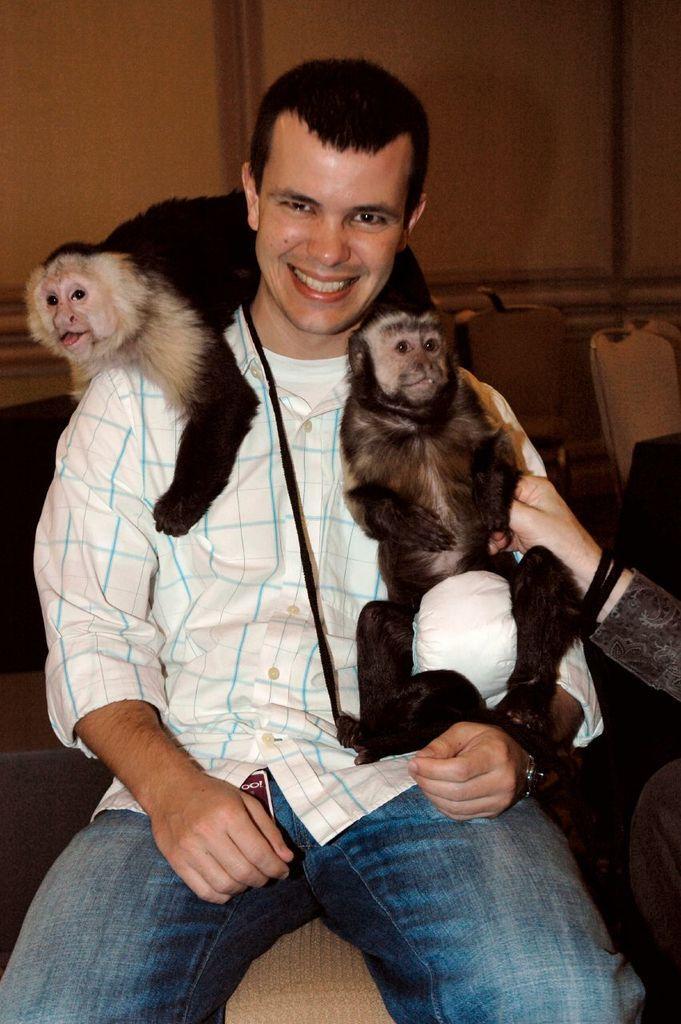How would you summarize this image in a sentence or two? This picture there is a man sitting in the chair and there are two monkeys on him. In the background there is a wall. 